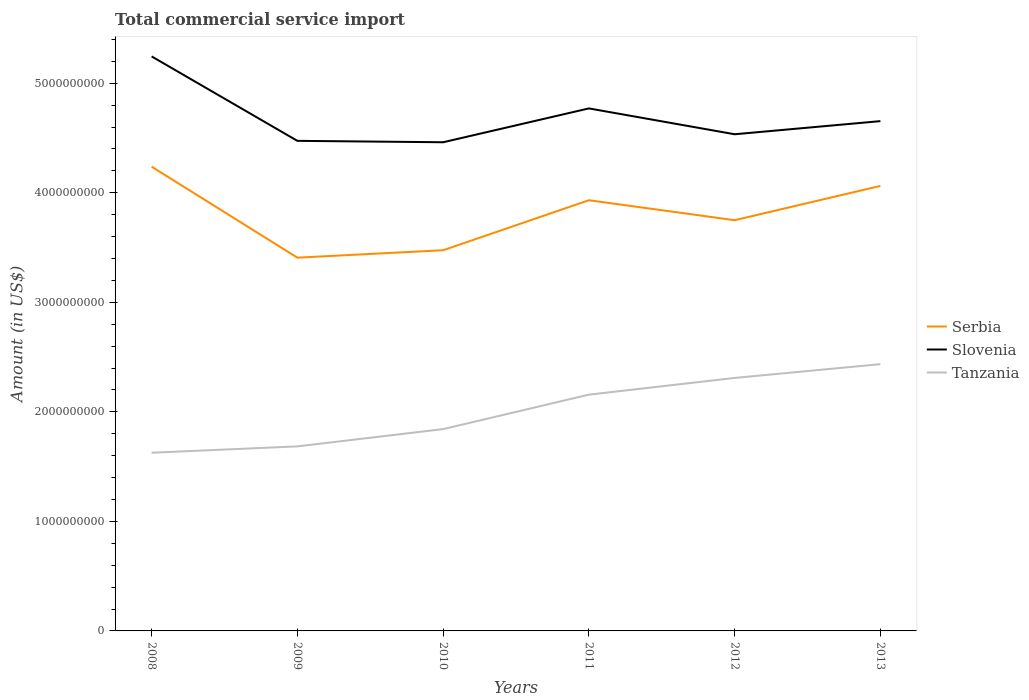Does the line corresponding to Serbia intersect with the line corresponding to Slovenia?
Provide a short and direct response. No. Across all years, what is the maximum total commercial service import in Slovenia?
Make the answer very short. 4.46e+09. What is the total total commercial service import in Slovenia in the graph?
Your answer should be compact. 7.71e+08. What is the difference between the highest and the second highest total commercial service import in Tanzania?
Your response must be concise. 8.09e+08. How many lines are there?
Make the answer very short. 3. Where does the legend appear in the graph?
Provide a short and direct response. Center right. How many legend labels are there?
Make the answer very short. 3. What is the title of the graph?
Offer a terse response. Total commercial service import. Does "Greenland" appear as one of the legend labels in the graph?
Provide a succinct answer. No. What is the label or title of the X-axis?
Your answer should be very brief. Years. What is the Amount (in US$) in Serbia in 2008?
Your answer should be compact. 4.24e+09. What is the Amount (in US$) in Slovenia in 2008?
Your response must be concise. 5.25e+09. What is the Amount (in US$) in Tanzania in 2008?
Make the answer very short. 1.63e+09. What is the Amount (in US$) of Serbia in 2009?
Your answer should be compact. 3.41e+09. What is the Amount (in US$) of Slovenia in 2009?
Provide a short and direct response. 4.47e+09. What is the Amount (in US$) in Tanzania in 2009?
Your answer should be very brief. 1.68e+09. What is the Amount (in US$) of Serbia in 2010?
Your response must be concise. 3.48e+09. What is the Amount (in US$) of Slovenia in 2010?
Your response must be concise. 4.46e+09. What is the Amount (in US$) of Tanzania in 2010?
Ensure brevity in your answer.  1.84e+09. What is the Amount (in US$) of Serbia in 2011?
Ensure brevity in your answer.  3.93e+09. What is the Amount (in US$) in Slovenia in 2011?
Give a very brief answer. 4.77e+09. What is the Amount (in US$) in Tanzania in 2011?
Offer a very short reply. 2.16e+09. What is the Amount (in US$) in Serbia in 2012?
Make the answer very short. 3.75e+09. What is the Amount (in US$) in Slovenia in 2012?
Make the answer very short. 4.53e+09. What is the Amount (in US$) in Tanzania in 2012?
Make the answer very short. 2.31e+09. What is the Amount (in US$) in Serbia in 2013?
Keep it short and to the point. 4.06e+09. What is the Amount (in US$) in Slovenia in 2013?
Offer a terse response. 4.65e+09. What is the Amount (in US$) in Tanzania in 2013?
Your answer should be very brief. 2.44e+09. Across all years, what is the maximum Amount (in US$) in Serbia?
Ensure brevity in your answer.  4.24e+09. Across all years, what is the maximum Amount (in US$) of Slovenia?
Your answer should be very brief. 5.25e+09. Across all years, what is the maximum Amount (in US$) in Tanzania?
Offer a terse response. 2.44e+09. Across all years, what is the minimum Amount (in US$) of Serbia?
Make the answer very short. 3.41e+09. Across all years, what is the minimum Amount (in US$) in Slovenia?
Offer a terse response. 4.46e+09. Across all years, what is the minimum Amount (in US$) in Tanzania?
Provide a succinct answer. 1.63e+09. What is the total Amount (in US$) in Serbia in the graph?
Give a very brief answer. 2.29e+1. What is the total Amount (in US$) of Slovenia in the graph?
Keep it short and to the point. 2.81e+1. What is the total Amount (in US$) of Tanzania in the graph?
Make the answer very short. 1.21e+1. What is the difference between the Amount (in US$) of Serbia in 2008 and that in 2009?
Offer a terse response. 8.31e+08. What is the difference between the Amount (in US$) of Slovenia in 2008 and that in 2009?
Offer a very short reply. 7.71e+08. What is the difference between the Amount (in US$) of Tanzania in 2008 and that in 2009?
Keep it short and to the point. -5.79e+07. What is the difference between the Amount (in US$) in Serbia in 2008 and that in 2010?
Keep it short and to the point. 7.63e+08. What is the difference between the Amount (in US$) in Slovenia in 2008 and that in 2010?
Your answer should be very brief. 7.84e+08. What is the difference between the Amount (in US$) of Tanzania in 2008 and that in 2010?
Your answer should be compact. -2.16e+08. What is the difference between the Amount (in US$) of Serbia in 2008 and that in 2011?
Make the answer very short. 3.06e+08. What is the difference between the Amount (in US$) in Slovenia in 2008 and that in 2011?
Make the answer very short. 4.75e+08. What is the difference between the Amount (in US$) in Tanzania in 2008 and that in 2011?
Your answer should be very brief. -5.30e+08. What is the difference between the Amount (in US$) in Serbia in 2008 and that in 2012?
Provide a succinct answer. 4.89e+08. What is the difference between the Amount (in US$) of Slovenia in 2008 and that in 2012?
Make the answer very short. 7.11e+08. What is the difference between the Amount (in US$) in Tanzania in 2008 and that in 2012?
Keep it short and to the point. -6.83e+08. What is the difference between the Amount (in US$) of Serbia in 2008 and that in 2013?
Keep it short and to the point. 1.76e+08. What is the difference between the Amount (in US$) of Slovenia in 2008 and that in 2013?
Your answer should be compact. 5.91e+08. What is the difference between the Amount (in US$) in Tanzania in 2008 and that in 2013?
Your response must be concise. -8.09e+08. What is the difference between the Amount (in US$) in Serbia in 2009 and that in 2010?
Your response must be concise. -6.78e+07. What is the difference between the Amount (in US$) in Slovenia in 2009 and that in 2010?
Provide a succinct answer. 1.28e+07. What is the difference between the Amount (in US$) of Tanzania in 2009 and that in 2010?
Your answer should be compact. -1.58e+08. What is the difference between the Amount (in US$) of Serbia in 2009 and that in 2011?
Ensure brevity in your answer.  -5.24e+08. What is the difference between the Amount (in US$) of Slovenia in 2009 and that in 2011?
Your answer should be very brief. -2.96e+08. What is the difference between the Amount (in US$) of Tanzania in 2009 and that in 2011?
Ensure brevity in your answer.  -4.72e+08. What is the difference between the Amount (in US$) of Serbia in 2009 and that in 2012?
Your response must be concise. -3.42e+08. What is the difference between the Amount (in US$) in Slovenia in 2009 and that in 2012?
Keep it short and to the point. -6.03e+07. What is the difference between the Amount (in US$) of Tanzania in 2009 and that in 2012?
Ensure brevity in your answer.  -6.25e+08. What is the difference between the Amount (in US$) of Serbia in 2009 and that in 2013?
Ensure brevity in your answer.  -6.55e+08. What is the difference between the Amount (in US$) in Slovenia in 2009 and that in 2013?
Your answer should be very brief. -1.80e+08. What is the difference between the Amount (in US$) of Tanzania in 2009 and that in 2013?
Your answer should be compact. -7.51e+08. What is the difference between the Amount (in US$) of Serbia in 2010 and that in 2011?
Give a very brief answer. -4.57e+08. What is the difference between the Amount (in US$) in Slovenia in 2010 and that in 2011?
Ensure brevity in your answer.  -3.09e+08. What is the difference between the Amount (in US$) in Tanzania in 2010 and that in 2011?
Your answer should be compact. -3.15e+08. What is the difference between the Amount (in US$) in Serbia in 2010 and that in 2012?
Your answer should be compact. -2.74e+08. What is the difference between the Amount (in US$) of Slovenia in 2010 and that in 2012?
Provide a succinct answer. -7.31e+07. What is the difference between the Amount (in US$) of Tanzania in 2010 and that in 2012?
Offer a terse response. -4.67e+08. What is the difference between the Amount (in US$) of Serbia in 2010 and that in 2013?
Your answer should be compact. -5.87e+08. What is the difference between the Amount (in US$) in Slovenia in 2010 and that in 2013?
Your response must be concise. -1.93e+08. What is the difference between the Amount (in US$) of Tanzania in 2010 and that in 2013?
Keep it short and to the point. -5.93e+08. What is the difference between the Amount (in US$) of Serbia in 2011 and that in 2012?
Your answer should be compact. 1.82e+08. What is the difference between the Amount (in US$) of Slovenia in 2011 and that in 2012?
Your response must be concise. 2.36e+08. What is the difference between the Amount (in US$) of Tanzania in 2011 and that in 2012?
Provide a short and direct response. -1.53e+08. What is the difference between the Amount (in US$) of Serbia in 2011 and that in 2013?
Your answer should be very brief. -1.31e+08. What is the difference between the Amount (in US$) of Slovenia in 2011 and that in 2013?
Provide a short and direct response. 1.16e+08. What is the difference between the Amount (in US$) of Tanzania in 2011 and that in 2013?
Ensure brevity in your answer.  -2.78e+08. What is the difference between the Amount (in US$) in Serbia in 2012 and that in 2013?
Ensure brevity in your answer.  -3.13e+08. What is the difference between the Amount (in US$) of Slovenia in 2012 and that in 2013?
Give a very brief answer. -1.20e+08. What is the difference between the Amount (in US$) in Tanzania in 2012 and that in 2013?
Provide a short and direct response. -1.26e+08. What is the difference between the Amount (in US$) in Serbia in 2008 and the Amount (in US$) in Slovenia in 2009?
Your response must be concise. -2.36e+08. What is the difference between the Amount (in US$) of Serbia in 2008 and the Amount (in US$) of Tanzania in 2009?
Offer a very short reply. 2.55e+09. What is the difference between the Amount (in US$) of Slovenia in 2008 and the Amount (in US$) of Tanzania in 2009?
Your answer should be compact. 3.56e+09. What is the difference between the Amount (in US$) of Serbia in 2008 and the Amount (in US$) of Slovenia in 2010?
Give a very brief answer. -2.23e+08. What is the difference between the Amount (in US$) of Serbia in 2008 and the Amount (in US$) of Tanzania in 2010?
Provide a short and direct response. 2.40e+09. What is the difference between the Amount (in US$) in Slovenia in 2008 and the Amount (in US$) in Tanzania in 2010?
Make the answer very short. 3.40e+09. What is the difference between the Amount (in US$) in Serbia in 2008 and the Amount (in US$) in Slovenia in 2011?
Provide a short and direct response. -5.32e+08. What is the difference between the Amount (in US$) of Serbia in 2008 and the Amount (in US$) of Tanzania in 2011?
Offer a very short reply. 2.08e+09. What is the difference between the Amount (in US$) in Slovenia in 2008 and the Amount (in US$) in Tanzania in 2011?
Provide a succinct answer. 3.09e+09. What is the difference between the Amount (in US$) in Serbia in 2008 and the Amount (in US$) in Slovenia in 2012?
Make the answer very short. -2.96e+08. What is the difference between the Amount (in US$) in Serbia in 2008 and the Amount (in US$) in Tanzania in 2012?
Offer a very short reply. 1.93e+09. What is the difference between the Amount (in US$) of Slovenia in 2008 and the Amount (in US$) of Tanzania in 2012?
Make the answer very short. 2.94e+09. What is the difference between the Amount (in US$) of Serbia in 2008 and the Amount (in US$) of Slovenia in 2013?
Ensure brevity in your answer.  -4.16e+08. What is the difference between the Amount (in US$) of Serbia in 2008 and the Amount (in US$) of Tanzania in 2013?
Keep it short and to the point. 1.80e+09. What is the difference between the Amount (in US$) in Slovenia in 2008 and the Amount (in US$) in Tanzania in 2013?
Give a very brief answer. 2.81e+09. What is the difference between the Amount (in US$) in Serbia in 2009 and the Amount (in US$) in Slovenia in 2010?
Give a very brief answer. -1.05e+09. What is the difference between the Amount (in US$) of Serbia in 2009 and the Amount (in US$) of Tanzania in 2010?
Offer a terse response. 1.57e+09. What is the difference between the Amount (in US$) of Slovenia in 2009 and the Amount (in US$) of Tanzania in 2010?
Make the answer very short. 2.63e+09. What is the difference between the Amount (in US$) in Serbia in 2009 and the Amount (in US$) in Slovenia in 2011?
Your response must be concise. -1.36e+09. What is the difference between the Amount (in US$) in Serbia in 2009 and the Amount (in US$) in Tanzania in 2011?
Keep it short and to the point. 1.25e+09. What is the difference between the Amount (in US$) of Slovenia in 2009 and the Amount (in US$) of Tanzania in 2011?
Your answer should be compact. 2.32e+09. What is the difference between the Amount (in US$) of Serbia in 2009 and the Amount (in US$) of Slovenia in 2012?
Provide a succinct answer. -1.13e+09. What is the difference between the Amount (in US$) of Serbia in 2009 and the Amount (in US$) of Tanzania in 2012?
Your answer should be very brief. 1.10e+09. What is the difference between the Amount (in US$) in Slovenia in 2009 and the Amount (in US$) in Tanzania in 2012?
Your answer should be compact. 2.16e+09. What is the difference between the Amount (in US$) in Serbia in 2009 and the Amount (in US$) in Slovenia in 2013?
Your answer should be compact. -1.25e+09. What is the difference between the Amount (in US$) of Serbia in 2009 and the Amount (in US$) of Tanzania in 2013?
Ensure brevity in your answer.  9.72e+08. What is the difference between the Amount (in US$) of Slovenia in 2009 and the Amount (in US$) of Tanzania in 2013?
Offer a very short reply. 2.04e+09. What is the difference between the Amount (in US$) of Serbia in 2010 and the Amount (in US$) of Slovenia in 2011?
Keep it short and to the point. -1.29e+09. What is the difference between the Amount (in US$) in Serbia in 2010 and the Amount (in US$) in Tanzania in 2011?
Provide a succinct answer. 1.32e+09. What is the difference between the Amount (in US$) of Slovenia in 2010 and the Amount (in US$) of Tanzania in 2011?
Your answer should be compact. 2.30e+09. What is the difference between the Amount (in US$) of Serbia in 2010 and the Amount (in US$) of Slovenia in 2012?
Offer a very short reply. -1.06e+09. What is the difference between the Amount (in US$) in Serbia in 2010 and the Amount (in US$) in Tanzania in 2012?
Your answer should be very brief. 1.17e+09. What is the difference between the Amount (in US$) in Slovenia in 2010 and the Amount (in US$) in Tanzania in 2012?
Offer a very short reply. 2.15e+09. What is the difference between the Amount (in US$) of Serbia in 2010 and the Amount (in US$) of Slovenia in 2013?
Give a very brief answer. -1.18e+09. What is the difference between the Amount (in US$) in Serbia in 2010 and the Amount (in US$) in Tanzania in 2013?
Provide a succinct answer. 1.04e+09. What is the difference between the Amount (in US$) of Slovenia in 2010 and the Amount (in US$) of Tanzania in 2013?
Give a very brief answer. 2.03e+09. What is the difference between the Amount (in US$) of Serbia in 2011 and the Amount (in US$) of Slovenia in 2012?
Make the answer very short. -6.02e+08. What is the difference between the Amount (in US$) of Serbia in 2011 and the Amount (in US$) of Tanzania in 2012?
Offer a terse response. 1.62e+09. What is the difference between the Amount (in US$) in Slovenia in 2011 and the Amount (in US$) in Tanzania in 2012?
Offer a terse response. 2.46e+09. What is the difference between the Amount (in US$) in Serbia in 2011 and the Amount (in US$) in Slovenia in 2013?
Your response must be concise. -7.22e+08. What is the difference between the Amount (in US$) in Serbia in 2011 and the Amount (in US$) in Tanzania in 2013?
Your answer should be very brief. 1.50e+09. What is the difference between the Amount (in US$) in Slovenia in 2011 and the Amount (in US$) in Tanzania in 2013?
Your answer should be compact. 2.34e+09. What is the difference between the Amount (in US$) in Serbia in 2012 and the Amount (in US$) in Slovenia in 2013?
Offer a very short reply. -9.05e+08. What is the difference between the Amount (in US$) in Serbia in 2012 and the Amount (in US$) in Tanzania in 2013?
Offer a very short reply. 1.31e+09. What is the difference between the Amount (in US$) in Slovenia in 2012 and the Amount (in US$) in Tanzania in 2013?
Your answer should be very brief. 2.10e+09. What is the average Amount (in US$) of Serbia per year?
Ensure brevity in your answer.  3.81e+09. What is the average Amount (in US$) of Slovenia per year?
Your response must be concise. 4.69e+09. What is the average Amount (in US$) of Tanzania per year?
Your response must be concise. 2.01e+09. In the year 2008, what is the difference between the Amount (in US$) in Serbia and Amount (in US$) in Slovenia?
Provide a succinct answer. -1.01e+09. In the year 2008, what is the difference between the Amount (in US$) in Serbia and Amount (in US$) in Tanzania?
Make the answer very short. 2.61e+09. In the year 2008, what is the difference between the Amount (in US$) of Slovenia and Amount (in US$) of Tanzania?
Your answer should be very brief. 3.62e+09. In the year 2009, what is the difference between the Amount (in US$) of Serbia and Amount (in US$) of Slovenia?
Ensure brevity in your answer.  -1.07e+09. In the year 2009, what is the difference between the Amount (in US$) of Serbia and Amount (in US$) of Tanzania?
Your answer should be compact. 1.72e+09. In the year 2009, what is the difference between the Amount (in US$) of Slovenia and Amount (in US$) of Tanzania?
Make the answer very short. 2.79e+09. In the year 2010, what is the difference between the Amount (in US$) in Serbia and Amount (in US$) in Slovenia?
Give a very brief answer. -9.86e+08. In the year 2010, what is the difference between the Amount (in US$) of Serbia and Amount (in US$) of Tanzania?
Your answer should be very brief. 1.63e+09. In the year 2010, what is the difference between the Amount (in US$) in Slovenia and Amount (in US$) in Tanzania?
Ensure brevity in your answer.  2.62e+09. In the year 2011, what is the difference between the Amount (in US$) of Serbia and Amount (in US$) of Slovenia?
Give a very brief answer. -8.38e+08. In the year 2011, what is the difference between the Amount (in US$) in Serbia and Amount (in US$) in Tanzania?
Give a very brief answer. 1.78e+09. In the year 2011, what is the difference between the Amount (in US$) of Slovenia and Amount (in US$) of Tanzania?
Make the answer very short. 2.61e+09. In the year 2012, what is the difference between the Amount (in US$) of Serbia and Amount (in US$) of Slovenia?
Keep it short and to the point. -7.85e+08. In the year 2012, what is the difference between the Amount (in US$) of Serbia and Amount (in US$) of Tanzania?
Give a very brief answer. 1.44e+09. In the year 2012, what is the difference between the Amount (in US$) in Slovenia and Amount (in US$) in Tanzania?
Your answer should be compact. 2.22e+09. In the year 2013, what is the difference between the Amount (in US$) in Serbia and Amount (in US$) in Slovenia?
Provide a succinct answer. -5.92e+08. In the year 2013, what is the difference between the Amount (in US$) of Serbia and Amount (in US$) of Tanzania?
Give a very brief answer. 1.63e+09. In the year 2013, what is the difference between the Amount (in US$) of Slovenia and Amount (in US$) of Tanzania?
Your response must be concise. 2.22e+09. What is the ratio of the Amount (in US$) of Serbia in 2008 to that in 2009?
Offer a terse response. 1.24. What is the ratio of the Amount (in US$) of Slovenia in 2008 to that in 2009?
Provide a succinct answer. 1.17. What is the ratio of the Amount (in US$) of Tanzania in 2008 to that in 2009?
Your answer should be compact. 0.97. What is the ratio of the Amount (in US$) of Serbia in 2008 to that in 2010?
Your answer should be very brief. 1.22. What is the ratio of the Amount (in US$) in Slovenia in 2008 to that in 2010?
Ensure brevity in your answer.  1.18. What is the ratio of the Amount (in US$) of Tanzania in 2008 to that in 2010?
Make the answer very short. 0.88. What is the ratio of the Amount (in US$) in Serbia in 2008 to that in 2011?
Keep it short and to the point. 1.08. What is the ratio of the Amount (in US$) of Slovenia in 2008 to that in 2011?
Your answer should be very brief. 1.1. What is the ratio of the Amount (in US$) of Tanzania in 2008 to that in 2011?
Give a very brief answer. 0.75. What is the ratio of the Amount (in US$) of Serbia in 2008 to that in 2012?
Your response must be concise. 1.13. What is the ratio of the Amount (in US$) in Slovenia in 2008 to that in 2012?
Offer a terse response. 1.16. What is the ratio of the Amount (in US$) of Tanzania in 2008 to that in 2012?
Give a very brief answer. 0.7. What is the ratio of the Amount (in US$) in Serbia in 2008 to that in 2013?
Offer a terse response. 1.04. What is the ratio of the Amount (in US$) in Slovenia in 2008 to that in 2013?
Provide a succinct answer. 1.13. What is the ratio of the Amount (in US$) of Tanzania in 2008 to that in 2013?
Your response must be concise. 0.67. What is the ratio of the Amount (in US$) of Serbia in 2009 to that in 2010?
Your answer should be very brief. 0.98. What is the ratio of the Amount (in US$) of Tanzania in 2009 to that in 2010?
Offer a terse response. 0.91. What is the ratio of the Amount (in US$) in Serbia in 2009 to that in 2011?
Provide a short and direct response. 0.87. What is the ratio of the Amount (in US$) in Slovenia in 2009 to that in 2011?
Provide a short and direct response. 0.94. What is the ratio of the Amount (in US$) of Tanzania in 2009 to that in 2011?
Ensure brevity in your answer.  0.78. What is the ratio of the Amount (in US$) of Serbia in 2009 to that in 2012?
Make the answer very short. 0.91. What is the ratio of the Amount (in US$) in Slovenia in 2009 to that in 2012?
Keep it short and to the point. 0.99. What is the ratio of the Amount (in US$) in Tanzania in 2009 to that in 2012?
Give a very brief answer. 0.73. What is the ratio of the Amount (in US$) in Serbia in 2009 to that in 2013?
Offer a very short reply. 0.84. What is the ratio of the Amount (in US$) in Slovenia in 2009 to that in 2013?
Make the answer very short. 0.96. What is the ratio of the Amount (in US$) of Tanzania in 2009 to that in 2013?
Offer a very short reply. 0.69. What is the ratio of the Amount (in US$) of Serbia in 2010 to that in 2011?
Your answer should be very brief. 0.88. What is the ratio of the Amount (in US$) in Slovenia in 2010 to that in 2011?
Give a very brief answer. 0.94. What is the ratio of the Amount (in US$) in Tanzania in 2010 to that in 2011?
Offer a terse response. 0.85. What is the ratio of the Amount (in US$) of Serbia in 2010 to that in 2012?
Ensure brevity in your answer.  0.93. What is the ratio of the Amount (in US$) of Slovenia in 2010 to that in 2012?
Your response must be concise. 0.98. What is the ratio of the Amount (in US$) of Tanzania in 2010 to that in 2012?
Provide a short and direct response. 0.8. What is the ratio of the Amount (in US$) in Serbia in 2010 to that in 2013?
Your response must be concise. 0.86. What is the ratio of the Amount (in US$) in Slovenia in 2010 to that in 2013?
Provide a short and direct response. 0.96. What is the ratio of the Amount (in US$) in Tanzania in 2010 to that in 2013?
Keep it short and to the point. 0.76. What is the ratio of the Amount (in US$) in Serbia in 2011 to that in 2012?
Give a very brief answer. 1.05. What is the ratio of the Amount (in US$) in Slovenia in 2011 to that in 2012?
Offer a very short reply. 1.05. What is the ratio of the Amount (in US$) in Tanzania in 2011 to that in 2012?
Keep it short and to the point. 0.93. What is the ratio of the Amount (in US$) in Serbia in 2011 to that in 2013?
Your answer should be very brief. 0.97. What is the ratio of the Amount (in US$) in Tanzania in 2011 to that in 2013?
Your response must be concise. 0.89. What is the ratio of the Amount (in US$) of Serbia in 2012 to that in 2013?
Keep it short and to the point. 0.92. What is the ratio of the Amount (in US$) in Slovenia in 2012 to that in 2013?
Your answer should be very brief. 0.97. What is the ratio of the Amount (in US$) in Tanzania in 2012 to that in 2013?
Offer a very short reply. 0.95. What is the difference between the highest and the second highest Amount (in US$) of Serbia?
Provide a succinct answer. 1.76e+08. What is the difference between the highest and the second highest Amount (in US$) in Slovenia?
Give a very brief answer. 4.75e+08. What is the difference between the highest and the second highest Amount (in US$) of Tanzania?
Provide a short and direct response. 1.26e+08. What is the difference between the highest and the lowest Amount (in US$) of Serbia?
Ensure brevity in your answer.  8.31e+08. What is the difference between the highest and the lowest Amount (in US$) of Slovenia?
Ensure brevity in your answer.  7.84e+08. What is the difference between the highest and the lowest Amount (in US$) of Tanzania?
Offer a very short reply. 8.09e+08. 